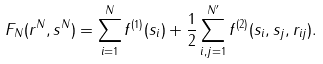Convert formula to latex. <formula><loc_0><loc_0><loc_500><loc_500>F _ { N } ( { r } ^ { N } , s ^ { N } ) = \sum _ { i = 1 } ^ { N } f ^ { ( 1 ) } ( s _ { i } ) + \frac { 1 } { 2 } \sum _ { i , j = 1 } ^ { N ^ { \prime } } f ^ { ( 2 ) } ( s _ { i } , s _ { j } , r _ { i j } ) .</formula> 